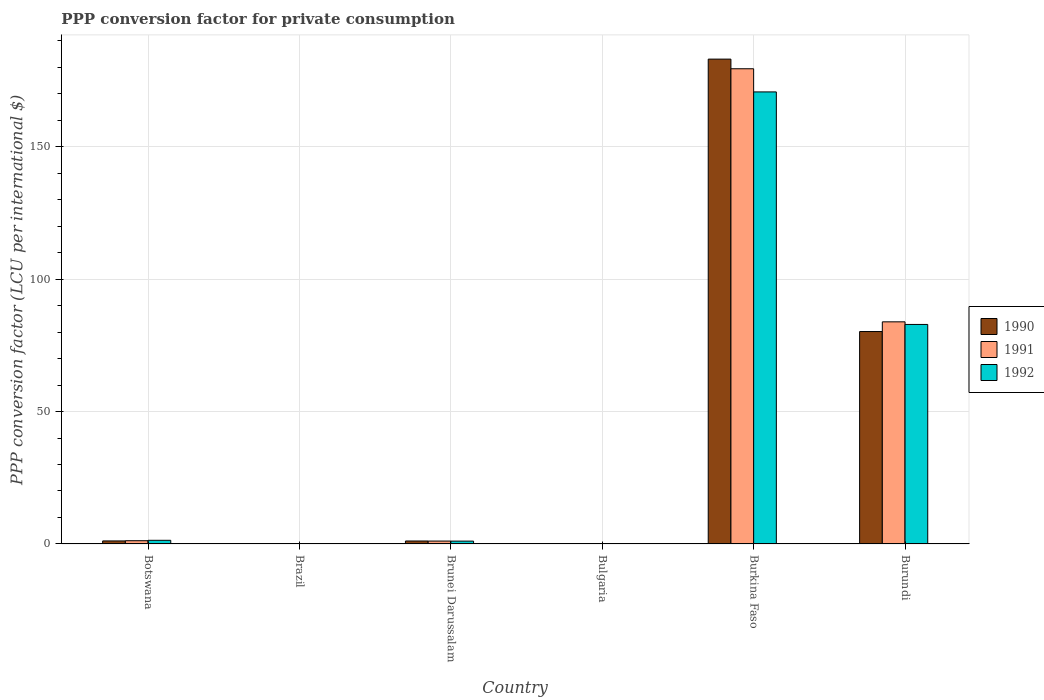How many different coloured bars are there?
Provide a succinct answer. 3. How many groups of bars are there?
Your answer should be very brief. 6. Are the number of bars on each tick of the X-axis equal?
Provide a succinct answer. Yes. How many bars are there on the 4th tick from the right?
Make the answer very short. 3. What is the label of the 6th group of bars from the left?
Make the answer very short. Burundi. What is the PPP conversion factor for private consumption in 1991 in Brazil?
Your answer should be very brief. 0. Across all countries, what is the maximum PPP conversion factor for private consumption in 1991?
Your answer should be compact. 179.42. Across all countries, what is the minimum PPP conversion factor for private consumption in 1992?
Offer a terse response. 0. In which country was the PPP conversion factor for private consumption in 1991 maximum?
Give a very brief answer. Burkina Faso. In which country was the PPP conversion factor for private consumption in 1992 minimum?
Your answer should be compact. Brazil. What is the total PPP conversion factor for private consumption in 1990 in the graph?
Offer a very short reply. 265.53. What is the difference between the PPP conversion factor for private consumption in 1990 in Brazil and that in Brunei Darussalam?
Provide a short and direct response. -1.12. What is the difference between the PPP conversion factor for private consumption in 1990 in Burundi and the PPP conversion factor for private consumption in 1992 in Burkina Faso?
Your response must be concise. -90.47. What is the average PPP conversion factor for private consumption in 1992 per country?
Offer a very short reply. 42.67. What is the difference between the PPP conversion factor for private consumption of/in 1990 and PPP conversion factor for private consumption of/in 1991 in Brazil?
Provide a short and direct response. -9.83101504297712e-5. In how many countries, is the PPP conversion factor for private consumption in 1992 greater than 30 LCU?
Make the answer very short. 2. What is the ratio of the PPP conversion factor for private consumption in 1990 in Brazil to that in Burundi?
Make the answer very short. 2.981445265189759e-7. Is the PPP conversion factor for private consumption in 1992 in Botswana less than that in Brazil?
Keep it short and to the point. No. What is the difference between the highest and the second highest PPP conversion factor for private consumption in 1990?
Keep it short and to the point. 79.06. What is the difference between the highest and the lowest PPP conversion factor for private consumption in 1990?
Your response must be concise. 183.06. In how many countries, is the PPP conversion factor for private consumption in 1990 greater than the average PPP conversion factor for private consumption in 1990 taken over all countries?
Offer a very short reply. 2. How many bars are there?
Provide a succinct answer. 18. Are all the bars in the graph horizontal?
Make the answer very short. No. Does the graph contain grids?
Your response must be concise. Yes. Where does the legend appear in the graph?
Give a very brief answer. Center right. What is the title of the graph?
Your answer should be very brief. PPP conversion factor for private consumption. What is the label or title of the Y-axis?
Give a very brief answer. PPP conversion factor (LCU per international $). What is the PPP conversion factor (LCU per international $) of 1990 in Botswana?
Offer a terse response. 1.15. What is the PPP conversion factor (LCU per international $) in 1991 in Botswana?
Provide a succinct answer. 1.23. What is the PPP conversion factor (LCU per international $) of 1992 in Botswana?
Provide a succinct answer. 1.38. What is the PPP conversion factor (LCU per international $) of 1990 in Brazil?
Your response must be concise. 2.39117107766808e-5. What is the PPP conversion factor (LCU per international $) in 1991 in Brazil?
Offer a terse response. 0. What is the PPP conversion factor (LCU per international $) of 1992 in Brazil?
Your answer should be compact. 0. What is the PPP conversion factor (LCU per international $) of 1990 in Brunei Darussalam?
Keep it short and to the point. 1.12. What is the PPP conversion factor (LCU per international $) of 1991 in Brunei Darussalam?
Offer a terse response. 1.09. What is the PPP conversion factor (LCU per international $) of 1992 in Brunei Darussalam?
Make the answer very short. 1.08. What is the PPP conversion factor (LCU per international $) in 1990 in Bulgaria?
Provide a short and direct response. 0. What is the PPP conversion factor (LCU per international $) of 1991 in Bulgaria?
Keep it short and to the point. 0. What is the PPP conversion factor (LCU per international $) of 1992 in Bulgaria?
Keep it short and to the point. 0. What is the PPP conversion factor (LCU per international $) of 1990 in Burkina Faso?
Provide a short and direct response. 183.06. What is the PPP conversion factor (LCU per international $) in 1991 in Burkina Faso?
Make the answer very short. 179.42. What is the PPP conversion factor (LCU per international $) in 1992 in Burkina Faso?
Offer a terse response. 170.67. What is the PPP conversion factor (LCU per international $) in 1990 in Burundi?
Keep it short and to the point. 80.2. What is the PPP conversion factor (LCU per international $) in 1991 in Burundi?
Your answer should be very brief. 83.87. What is the PPP conversion factor (LCU per international $) of 1992 in Burundi?
Your answer should be compact. 82.88. Across all countries, what is the maximum PPP conversion factor (LCU per international $) in 1990?
Offer a terse response. 183.06. Across all countries, what is the maximum PPP conversion factor (LCU per international $) in 1991?
Make the answer very short. 179.42. Across all countries, what is the maximum PPP conversion factor (LCU per international $) of 1992?
Keep it short and to the point. 170.67. Across all countries, what is the minimum PPP conversion factor (LCU per international $) of 1990?
Your answer should be compact. 2.39117107766808e-5. Across all countries, what is the minimum PPP conversion factor (LCU per international $) in 1991?
Keep it short and to the point. 0. Across all countries, what is the minimum PPP conversion factor (LCU per international $) in 1992?
Offer a terse response. 0. What is the total PPP conversion factor (LCU per international $) in 1990 in the graph?
Your answer should be very brief. 265.53. What is the total PPP conversion factor (LCU per international $) in 1991 in the graph?
Provide a short and direct response. 265.61. What is the total PPP conversion factor (LCU per international $) in 1992 in the graph?
Provide a succinct answer. 256.03. What is the difference between the PPP conversion factor (LCU per international $) of 1990 in Botswana and that in Brazil?
Keep it short and to the point. 1.15. What is the difference between the PPP conversion factor (LCU per international $) of 1991 in Botswana and that in Brazil?
Keep it short and to the point. 1.23. What is the difference between the PPP conversion factor (LCU per international $) of 1992 in Botswana and that in Brazil?
Ensure brevity in your answer.  1.38. What is the difference between the PPP conversion factor (LCU per international $) in 1990 in Botswana and that in Brunei Darussalam?
Your response must be concise. 0.02. What is the difference between the PPP conversion factor (LCU per international $) in 1991 in Botswana and that in Brunei Darussalam?
Provide a succinct answer. 0.13. What is the difference between the PPP conversion factor (LCU per international $) in 1992 in Botswana and that in Brunei Darussalam?
Offer a terse response. 0.31. What is the difference between the PPP conversion factor (LCU per international $) in 1990 in Botswana and that in Bulgaria?
Your answer should be compact. 1.14. What is the difference between the PPP conversion factor (LCU per international $) of 1991 in Botswana and that in Bulgaria?
Your answer should be compact. 1.23. What is the difference between the PPP conversion factor (LCU per international $) in 1992 in Botswana and that in Bulgaria?
Provide a short and direct response. 1.38. What is the difference between the PPP conversion factor (LCU per international $) of 1990 in Botswana and that in Burkina Faso?
Give a very brief answer. -181.91. What is the difference between the PPP conversion factor (LCU per international $) of 1991 in Botswana and that in Burkina Faso?
Make the answer very short. -178.19. What is the difference between the PPP conversion factor (LCU per international $) of 1992 in Botswana and that in Burkina Faso?
Offer a terse response. -169.29. What is the difference between the PPP conversion factor (LCU per international $) of 1990 in Botswana and that in Burundi?
Ensure brevity in your answer.  -79.06. What is the difference between the PPP conversion factor (LCU per international $) of 1991 in Botswana and that in Burundi?
Offer a very short reply. -82.64. What is the difference between the PPP conversion factor (LCU per international $) in 1992 in Botswana and that in Burundi?
Offer a very short reply. -81.5. What is the difference between the PPP conversion factor (LCU per international $) in 1990 in Brazil and that in Brunei Darussalam?
Your response must be concise. -1.12. What is the difference between the PPP conversion factor (LCU per international $) of 1991 in Brazil and that in Brunei Darussalam?
Keep it short and to the point. -1.09. What is the difference between the PPP conversion factor (LCU per international $) in 1992 in Brazil and that in Brunei Darussalam?
Your answer should be very brief. -1.07. What is the difference between the PPP conversion factor (LCU per international $) of 1990 in Brazil and that in Bulgaria?
Ensure brevity in your answer.  -0. What is the difference between the PPP conversion factor (LCU per international $) in 1991 in Brazil and that in Bulgaria?
Provide a succinct answer. -0. What is the difference between the PPP conversion factor (LCU per international $) of 1992 in Brazil and that in Bulgaria?
Your answer should be very brief. -0. What is the difference between the PPP conversion factor (LCU per international $) in 1990 in Brazil and that in Burkina Faso?
Your answer should be very brief. -183.06. What is the difference between the PPP conversion factor (LCU per international $) in 1991 in Brazil and that in Burkina Faso?
Offer a terse response. -179.42. What is the difference between the PPP conversion factor (LCU per international $) in 1992 in Brazil and that in Burkina Faso?
Ensure brevity in your answer.  -170.67. What is the difference between the PPP conversion factor (LCU per international $) in 1990 in Brazil and that in Burundi?
Your response must be concise. -80.2. What is the difference between the PPP conversion factor (LCU per international $) in 1991 in Brazil and that in Burundi?
Your answer should be compact. -83.87. What is the difference between the PPP conversion factor (LCU per international $) of 1992 in Brazil and that in Burundi?
Provide a short and direct response. -82.88. What is the difference between the PPP conversion factor (LCU per international $) of 1990 in Brunei Darussalam and that in Bulgaria?
Provide a succinct answer. 1.12. What is the difference between the PPP conversion factor (LCU per international $) of 1991 in Brunei Darussalam and that in Bulgaria?
Your answer should be very brief. 1.09. What is the difference between the PPP conversion factor (LCU per international $) in 1992 in Brunei Darussalam and that in Bulgaria?
Your answer should be very brief. 1.07. What is the difference between the PPP conversion factor (LCU per international $) in 1990 in Brunei Darussalam and that in Burkina Faso?
Offer a terse response. -181.93. What is the difference between the PPP conversion factor (LCU per international $) in 1991 in Brunei Darussalam and that in Burkina Faso?
Provide a succinct answer. -178.32. What is the difference between the PPP conversion factor (LCU per international $) in 1992 in Brunei Darussalam and that in Burkina Faso?
Provide a succinct answer. -169.6. What is the difference between the PPP conversion factor (LCU per international $) in 1990 in Brunei Darussalam and that in Burundi?
Offer a terse response. -79.08. What is the difference between the PPP conversion factor (LCU per international $) in 1991 in Brunei Darussalam and that in Burundi?
Ensure brevity in your answer.  -82.77. What is the difference between the PPP conversion factor (LCU per international $) of 1992 in Brunei Darussalam and that in Burundi?
Make the answer very short. -81.81. What is the difference between the PPP conversion factor (LCU per international $) of 1990 in Bulgaria and that in Burkina Faso?
Your answer should be very brief. -183.06. What is the difference between the PPP conversion factor (LCU per international $) of 1991 in Bulgaria and that in Burkina Faso?
Ensure brevity in your answer.  -179.41. What is the difference between the PPP conversion factor (LCU per international $) of 1992 in Bulgaria and that in Burkina Faso?
Your response must be concise. -170.67. What is the difference between the PPP conversion factor (LCU per international $) of 1990 in Bulgaria and that in Burundi?
Make the answer very short. -80.2. What is the difference between the PPP conversion factor (LCU per international $) in 1991 in Bulgaria and that in Burundi?
Keep it short and to the point. -83.86. What is the difference between the PPP conversion factor (LCU per international $) of 1992 in Bulgaria and that in Burundi?
Offer a terse response. -82.88. What is the difference between the PPP conversion factor (LCU per international $) in 1990 in Burkina Faso and that in Burundi?
Provide a short and direct response. 102.85. What is the difference between the PPP conversion factor (LCU per international $) of 1991 in Burkina Faso and that in Burundi?
Your response must be concise. 95.55. What is the difference between the PPP conversion factor (LCU per international $) in 1992 in Burkina Faso and that in Burundi?
Ensure brevity in your answer.  87.79. What is the difference between the PPP conversion factor (LCU per international $) in 1990 in Botswana and the PPP conversion factor (LCU per international $) in 1991 in Brazil?
Ensure brevity in your answer.  1.15. What is the difference between the PPP conversion factor (LCU per international $) of 1990 in Botswana and the PPP conversion factor (LCU per international $) of 1992 in Brazil?
Give a very brief answer. 1.14. What is the difference between the PPP conversion factor (LCU per international $) in 1991 in Botswana and the PPP conversion factor (LCU per international $) in 1992 in Brazil?
Give a very brief answer. 1.23. What is the difference between the PPP conversion factor (LCU per international $) of 1990 in Botswana and the PPP conversion factor (LCU per international $) of 1991 in Brunei Darussalam?
Provide a succinct answer. 0.05. What is the difference between the PPP conversion factor (LCU per international $) of 1990 in Botswana and the PPP conversion factor (LCU per international $) of 1992 in Brunei Darussalam?
Your response must be concise. 0.07. What is the difference between the PPP conversion factor (LCU per international $) of 1991 in Botswana and the PPP conversion factor (LCU per international $) of 1992 in Brunei Darussalam?
Offer a very short reply. 0.15. What is the difference between the PPP conversion factor (LCU per international $) in 1990 in Botswana and the PPP conversion factor (LCU per international $) in 1991 in Bulgaria?
Your answer should be compact. 1.14. What is the difference between the PPP conversion factor (LCU per international $) of 1990 in Botswana and the PPP conversion factor (LCU per international $) of 1992 in Bulgaria?
Your answer should be very brief. 1.14. What is the difference between the PPP conversion factor (LCU per international $) in 1991 in Botswana and the PPP conversion factor (LCU per international $) in 1992 in Bulgaria?
Offer a terse response. 1.22. What is the difference between the PPP conversion factor (LCU per international $) in 1990 in Botswana and the PPP conversion factor (LCU per international $) in 1991 in Burkina Faso?
Make the answer very short. -178.27. What is the difference between the PPP conversion factor (LCU per international $) of 1990 in Botswana and the PPP conversion factor (LCU per international $) of 1992 in Burkina Faso?
Provide a short and direct response. -169.53. What is the difference between the PPP conversion factor (LCU per international $) in 1991 in Botswana and the PPP conversion factor (LCU per international $) in 1992 in Burkina Faso?
Your answer should be compact. -169.45. What is the difference between the PPP conversion factor (LCU per international $) in 1990 in Botswana and the PPP conversion factor (LCU per international $) in 1991 in Burundi?
Provide a succinct answer. -82.72. What is the difference between the PPP conversion factor (LCU per international $) of 1990 in Botswana and the PPP conversion factor (LCU per international $) of 1992 in Burundi?
Provide a short and direct response. -81.74. What is the difference between the PPP conversion factor (LCU per international $) of 1991 in Botswana and the PPP conversion factor (LCU per international $) of 1992 in Burundi?
Make the answer very short. -81.66. What is the difference between the PPP conversion factor (LCU per international $) in 1990 in Brazil and the PPP conversion factor (LCU per international $) in 1991 in Brunei Darussalam?
Your answer should be compact. -1.09. What is the difference between the PPP conversion factor (LCU per international $) of 1990 in Brazil and the PPP conversion factor (LCU per international $) of 1992 in Brunei Darussalam?
Offer a very short reply. -1.08. What is the difference between the PPP conversion factor (LCU per international $) in 1991 in Brazil and the PPP conversion factor (LCU per international $) in 1992 in Brunei Darussalam?
Your response must be concise. -1.08. What is the difference between the PPP conversion factor (LCU per international $) in 1990 in Brazil and the PPP conversion factor (LCU per international $) in 1991 in Bulgaria?
Your answer should be very brief. -0. What is the difference between the PPP conversion factor (LCU per international $) in 1990 in Brazil and the PPP conversion factor (LCU per international $) in 1992 in Bulgaria?
Keep it short and to the point. -0. What is the difference between the PPP conversion factor (LCU per international $) of 1991 in Brazil and the PPP conversion factor (LCU per international $) of 1992 in Bulgaria?
Your response must be concise. -0. What is the difference between the PPP conversion factor (LCU per international $) of 1990 in Brazil and the PPP conversion factor (LCU per international $) of 1991 in Burkina Faso?
Provide a short and direct response. -179.42. What is the difference between the PPP conversion factor (LCU per international $) in 1990 in Brazil and the PPP conversion factor (LCU per international $) in 1992 in Burkina Faso?
Offer a terse response. -170.67. What is the difference between the PPP conversion factor (LCU per international $) in 1991 in Brazil and the PPP conversion factor (LCU per international $) in 1992 in Burkina Faso?
Your answer should be very brief. -170.67. What is the difference between the PPP conversion factor (LCU per international $) in 1990 in Brazil and the PPP conversion factor (LCU per international $) in 1991 in Burundi?
Make the answer very short. -83.87. What is the difference between the PPP conversion factor (LCU per international $) in 1990 in Brazil and the PPP conversion factor (LCU per international $) in 1992 in Burundi?
Give a very brief answer. -82.88. What is the difference between the PPP conversion factor (LCU per international $) in 1991 in Brazil and the PPP conversion factor (LCU per international $) in 1992 in Burundi?
Your answer should be very brief. -82.88. What is the difference between the PPP conversion factor (LCU per international $) in 1990 in Brunei Darussalam and the PPP conversion factor (LCU per international $) in 1991 in Bulgaria?
Your answer should be compact. 1.12. What is the difference between the PPP conversion factor (LCU per international $) of 1990 in Brunei Darussalam and the PPP conversion factor (LCU per international $) of 1992 in Bulgaria?
Provide a succinct answer. 1.12. What is the difference between the PPP conversion factor (LCU per international $) of 1991 in Brunei Darussalam and the PPP conversion factor (LCU per international $) of 1992 in Bulgaria?
Give a very brief answer. 1.09. What is the difference between the PPP conversion factor (LCU per international $) in 1990 in Brunei Darussalam and the PPP conversion factor (LCU per international $) in 1991 in Burkina Faso?
Ensure brevity in your answer.  -178.29. What is the difference between the PPP conversion factor (LCU per international $) of 1990 in Brunei Darussalam and the PPP conversion factor (LCU per international $) of 1992 in Burkina Faso?
Offer a terse response. -169.55. What is the difference between the PPP conversion factor (LCU per international $) in 1991 in Brunei Darussalam and the PPP conversion factor (LCU per international $) in 1992 in Burkina Faso?
Your answer should be compact. -169.58. What is the difference between the PPP conversion factor (LCU per international $) of 1990 in Brunei Darussalam and the PPP conversion factor (LCU per international $) of 1991 in Burundi?
Your response must be concise. -82.74. What is the difference between the PPP conversion factor (LCU per international $) of 1990 in Brunei Darussalam and the PPP conversion factor (LCU per international $) of 1992 in Burundi?
Ensure brevity in your answer.  -81.76. What is the difference between the PPP conversion factor (LCU per international $) in 1991 in Brunei Darussalam and the PPP conversion factor (LCU per international $) in 1992 in Burundi?
Offer a very short reply. -81.79. What is the difference between the PPP conversion factor (LCU per international $) of 1990 in Bulgaria and the PPP conversion factor (LCU per international $) of 1991 in Burkina Faso?
Give a very brief answer. -179.42. What is the difference between the PPP conversion factor (LCU per international $) of 1990 in Bulgaria and the PPP conversion factor (LCU per international $) of 1992 in Burkina Faso?
Your answer should be very brief. -170.67. What is the difference between the PPP conversion factor (LCU per international $) in 1991 in Bulgaria and the PPP conversion factor (LCU per international $) in 1992 in Burkina Faso?
Offer a terse response. -170.67. What is the difference between the PPP conversion factor (LCU per international $) of 1990 in Bulgaria and the PPP conversion factor (LCU per international $) of 1991 in Burundi?
Give a very brief answer. -83.87. What is the difference between the PPP conversion factor (LCU per international $) in 1990 in Bulgaria and the PPP conversion factor (LCU per international $) in 1992 in Burundi?
Make the answer very short. -82.88. What is the difference between the PPP conversion factor (LCU per international $) of 1991 in Bulgaria and the PPP conversion factor (LCU per international $) of 1992 in Burundi?
Your response must be concise. -82.88. What is the difference between the PPP conversion factor (LCU per international $) of 1990 in Burkina Faso and the PPP conversion factor (LCU per international $) of 1991 in Burundi?
Your answer should be very brief. 99.19. What is the difference between the PPP conversion factor (LCU per international $) in 1990 in Burkina Faso and the PPP conversion factor (LCU per international $) in 1992 in Burundi?
Make the answer very short. 100.17. What is the difference between the PPP conversion factor (LCU per international $) of 1991 in Burkina Faso and the PPP conversion factor (LCU per international $) of 1992 in Burundi?
Your answer should be very brief. 96.53. What is the average PPP conversion factor (LCU per international $) of 1990 per country?
Your answer should be compact. 44.25. What is the average PPP conversion factor (LCU per international $) in 1991 per country?
Your response must be concise. 44.27. What is the average PPP conversion factor (LCU per international $) of 1992 per country?
Your answer should be very brief. 42.67. What is the difference between the PPP conversion factor (LCU per international $) of 1990 and PPP conversion factor (LCU per international $) of 1991 in Botswana?
Give a very brief answer. -0.08. What is the difference between the PPP conversion factor (LCU per international $) of 1990 and PPP conversion factor (LCU per international $) of 1992 in Botswana?
Make the answer very short. -0.24. What is the difference between the PPP conversion factor (LCU per international $) in 1991 and PPP conversion factor (LCU per international $) in 1992 in Botswana?
Your answer should be very brief. -0.16. What is the difference between the PPP conversion factor (LCU per international $) of 1990 and PPP conversion factor (LCU per international $) of 1991 in Brazil?
Make the answer very short. -0. What is the difference between the PPP conversion factor (LCU per international $) in 1990 and PPP conversion factor (LCU per international $) in 1992 in Brazil?
Provide a short and direct response. -0. What is the difference between the PPP conversion factor (LCU per international $) of 1991 and PPP conversion factor (LCU per international $) of 1992 in Brazil?
Ensure brevity in your answer.  -0. What is the difference between the PPP conversion factor (LCU per international $) in 1990 and PPP conversion factor (LCU per international $) in 1991 in Brunei Darussalam?
Offer a very short reply. 0.03. What is the difference between the PPP conversion factor (LCU per international $) in 1990 and PPP conversion factor (LCU per international $) in 1992 in Brunei Darussalam?
Offer a very short reply. 0.05. What is the difference between the PPP conversion factor (LCU per international $) in 1991 and PPP conversion factor (LCU per international $) in 1992 in Brunei Darussalam?
Provide a short and direct response. 0.02. What is the difference between the PPP conversion factor (LCU per international $) of 1990 and PPP conversion factor (LCU per international $) of 1991 in Bulgaria?
Your answer should be compact. -0. What is the difference between the PPP conversion factor (LCU per international $) of 1990 and PPP conversion factor (LCU per international $) of 1992 in Bulgaria?
Your answer should be very brief. -0. What is the difference between the PPP conversion factor (LCU per international $) of 1991 and PPP conversion factor (LCU per international $) of 1992 in Bulgaria?
Provide a succinct answer. -0. What is the difference between the PPP conversion factor (LCU per international $) in 1990 and PPP conversion factor (LCU per international $) in 1991 in Burkina Faso?
Offer a terse response. 3.64. What is the difference between the PPP conversion factor (LCU per international $) in 1990 and PPP conversion factor (LCU per international $) in 1992 in Burkina Faso?
Provide a succinct answer. 12.38. What is the difference between the PPP conversion factor (LCU per international $) of 1991 and PPP conversion factor (LCU per international $) of 1992 in Burkina Faso?
Offer a terse response. 8.74. What is the difference between the PPP conversion factor (LCU per international $) in 1990 and PPP conversion factor (LCU per international $) in 1991 in Burundi?
Keep it short and to the point. -3.66. What is the difference between the PPP conversion factor (LCU per international $) of 1990 and PPP conversion factor (LCU per international $) of 1992 in Burundi?
Make the answer very short. -2.68. What is the difference between the PPP conversion factor (LCU per international $) in 1991 and PPP conversion factor (LCU per international $) in 1992 in Burundi?
Your answer should be compact. 0.98. What is the ratio of the PPP conversion factor (LCU per international $) in 1990 in Botswana to that in Brazil?
Offer a very short reply. 4.79e+04. What is the ratio of the PPP conversion factor (LCU per international $) of 1991 in Botswana to that in Brazil?
Keep it short and to the point. 1.00e+04. What is the ratio of the PPP conversion factor (LCU per international $) in 1992 in Botswana to that in Brazil?
Your response must be concise. 1109.75. What is the ratio of the PPP conversion factor (LCU per international $) of 1990 in Botswana to that in Brunei Darussalam?
Give a very brief answer. 1.02. What is the ratio of the PPP conversion factor (LCU per international $) of 1991 in Botswana to that in Brunei Darussalam?
Give a very brief answer. 1.12. What is the ratio of the PPP conversion factor (LCU per international $) of 1992 in Botswana to that in Brunei Darussalam?
Offer a terse response. 1.29. What is the ratio of the PPP conversion factor (LCU per international $) in 1990 in Botswana to that in Bulgaria?
Ensure brevity in your answer.  1808.46. What is the ratio of the PPP conversion factor (LCU per international $) in 1991 in Botswana to that in Bulgaria?
Offer a very short reply. 461. What is the ratio of the PPP conversion factor (LCU per international $) of 1992 in Botswana to that in Bulgaria?
Provide a succinct answer. 279.94. What is the ratio of the PPP conversion factor (LCU per international $) in 1990 in Botswana to that in Burkina Faso?
Provide a succinct answer. 0.01. What is the ratio of the PPP conversion factor (LCU per international $) in 1991 in Botswana to that in Burkina Faso?
Offer a very short reply. 0.01. What is the ratio of the PPP conversion factor (LCU per international $) in 1992 in Botswana to that in Burkina Faso?
Ensure brevity in your answer.  0.01. What is the ratio of the PPP conversion factor (LCU per international $) of 1990 in Botswana to that in Burundi?
Provide a short and direct response. 0.01. What is the ratio of the PPP conversion factor (LCU per international $) in 1991 in Botswana to that in Burundi?
Offer a very short reply. 0.01. What is the ratio of the PPP conversion factor (LCU per international $) in 1992 in Botswana to that in Burundi?
Your answer should be compact. 0.02. What is the ratio of the PPP conversion factor (LCU per international $) of 1990 in Brazil to that in Brunei Darussalam?
Provide a succinct answer. 0. What is the ratio of the PPP conversion factor (LCU per international $) in 1992 in Brazil to that in Brunei Darussalam?
Make the answer very short. 0. What is the ratio of the PPP conversion factor (LCU per international $) in 1990 in Brazil to that in Bulgaria?
Your answer should be very brief. 0.04. What is the ratio of the PPP conversion factor (LCU per international $) of 1991 in Brazil to that in Bulgaria?
Ensure brevity in your answer.  0.05. What is the ratio of the PPP conversion factor (LCU per international $) in 1992 in Brazil to that in Bulgaria?
Ensure brevity in your answer.  0.25. What is the ratio of the PPP conversion factor (LCU per international $) of 1991 in Brazil to that in Burkina Faso?
Give a very brief answer. 0. What is the ratio of the PPP conversion factor (LCU per international $) of 1990 in Brazil to that in Burundi?
Offer a very short reply. 0. What is the ratio of the PPP conversion factor (LCU per international $) in 1992 in Brazil to that in Burundi?
Give a very brief answer. 0. What is the ratio of the PPP conversion factor (LCU per international $) of 1990 in Brunei Darussalam to that in Bulgaria?
Offer a very short reply. 1773.71. What is the ratio of the PPP conversion factor (LCU per international $) in 1991 in Brunei Darussalam to that in Bulgaria?
Your answer should be compact. 411.02. What is the ratio of the PPP conversion factor (LCU per international $) of 1992 in Brunei Darussalam to that in Bulgaria?
Provide a succinct answer. 217.61. What is the ratio of the PPP conversion factor (LCU per international $) of 1990 in Brunei Darussalam to that in Burkina Faso?
Make the answer very short. 0.01. What is the ratio of the PPP conversion factor (LCU per international $) in 1991 in Brunei Darussalam to that in Burkina Faso?
Offer a very short reply. 0.01. What is the ratio of the PPP conversion factor (LCU per international $) in 1992 in Brunei Darussalam to that in Burkina Faso?
Your answer should be very brief. 0.01. What is the ratio of the PPP conversion factor (LCU per international $) of 1990 in Brunei Darussalam to that in Burundi?
Your response must be concise. 0.01. What is the ratio of the PPP conversion factor (LCU per international $) in 1991 in Brunei Darussalam to that in Burundi?
Your answer should be very brief. 0.01. What is the ratio of the PPP conversion factor (LCU per international $) of 1992 in Brunei Darussalam to that in Burundi?
Offer a terse response. 0.01. What is the ratio of the PPP conversion factor (LCU per international $) of 1990 in Bulgaria to that in Burundi?
Keep it short and to the point. 0. What is the ratio of the PPP conversion factor (LCU per international $) in 1992 in Bulgaria to that in Burundi?
Give a very brief answer. 0. What is the ratio of the PPP conversion factor (LCU per international $) of 1990 in Burkina Faso to that in Burundi?
Ensure brevity in your answer.  2.28. What is the ratio of the PPP conversion factor (LCU per international $) in 1991 in Burkina Faso to that in Burundi?
Offer a very short reply. 2.14. What is the ratio of the PPP conversion factor (LCU per international $) of 1992 in Burkina Faso to that in Burundi?
Offer a terse response. 2.06. What is the difference between the highest and the second highest PPP conversion factor (LCU per international $) in 1990?
Ensure brevity in your answer.  102.85. What is the difference between the highest and the second highest PPP conversion factor (LCU per international $) of 1991?
Offer a terse response. 95.55. What is the difference between the highest and the second highest PPP conversion factor (LCU per international $) of 1992?
Make the answer very short. 87.79. What is the difference between the highest and the lowest PPP conversion factor (LCU per international $) in 1990?
Provide a short and direct response. 183.06. What is the difference between the highest and the lowest PPP conversion factor (LCU per international $) in 1991?
Keep it short and to the point. 179.42. What is the difference between the highest and the lowest PPP conversion factor (LCU per international $) in 1992?
Your answer should be very brief. 170.67. 